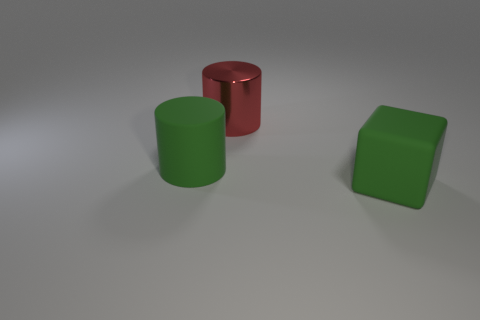The thing that is made of the same material as the cube is what color?
Make the answer very short. Green. There is a red shiny thing; does it have the same shape as the green rubber thing behind the big cube?
Make the answer very short. Yes. There is a block; are there any matte blocks to the right of it?
Make the answer very short. No. There is a large thing that is the same color as the large matte block; what is it made of?
Ensure brevity in your answer.  Rubber. There is a red cylinder; is its size the same as the rubber thing that is on the left side of the rubber block?
Offer a terse response. Yes. Are there any cubes of the same color as the large metallic thing?
Your response must be concise. No. Are there any tiny gray objects of the same shape as the red object?
Ensure brevity in your answer.  No. What shape is the large thing that is in front of the red cylinder and behind the matte cube?
Ensure brevity in your answer.  Cylinder. What number of large things have the same material as the green cube?
Offer a very short reply. 1. Is the number of big metallic cylinders to the right of the red thing less than the number of big green blocks?
Make the answer very short. Yes. 